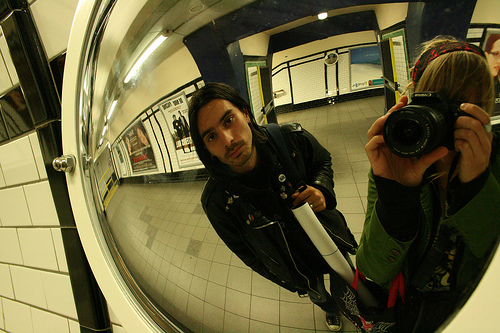<image>
Is there a paper tube in front of the leather jacket? Yes. The paper tube is positioned in front of the leather jacket, appearing closer to the camera viewpoint. 